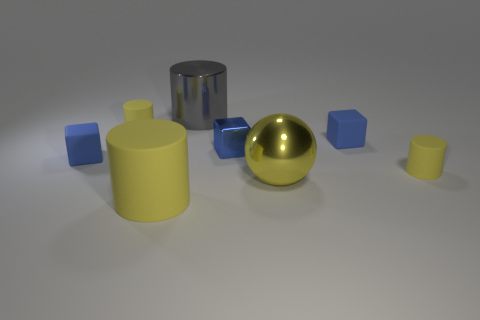There is a metallic sphere that is the same color as the large rubber object; what is its size?
Make the answer very short. Large. Is there a block made of the same material as the big yellow cylinder?
Your response must be concise. Yes. The large yellow matte thing is what shape?
Offer a very short reply. Cylinder. There is a matte thing that is to the left of the small yellow matte cylinder left of the large yellow matte cylinder; what shape is it?
Your answer should be compact. Cube. How many other things are there of the same shape as the small metal thing?
Your response must be concise. 2. What is the size of the gray metallic thing that is behind the object in front of the large yellow ball?
Keep it short and to the point. Large. Are any small shiny cylinders visible?
Offer a very short reply. No. There is a yellow rubber cylinder that is behind the blue shiny block; how many yellow matte cylinders are in front of it?
Offer a very short reply. 2. What shape is the big metallic thing that is on the left side of the big yellow shiny sphere?
Make the answer very short. Cylinder. There is a yellow ball that is right of the large cylinder that is on the right side of the large cylinder in front of the small blue metallic block; what is its material?
Provide a succinct answer. Metal. 